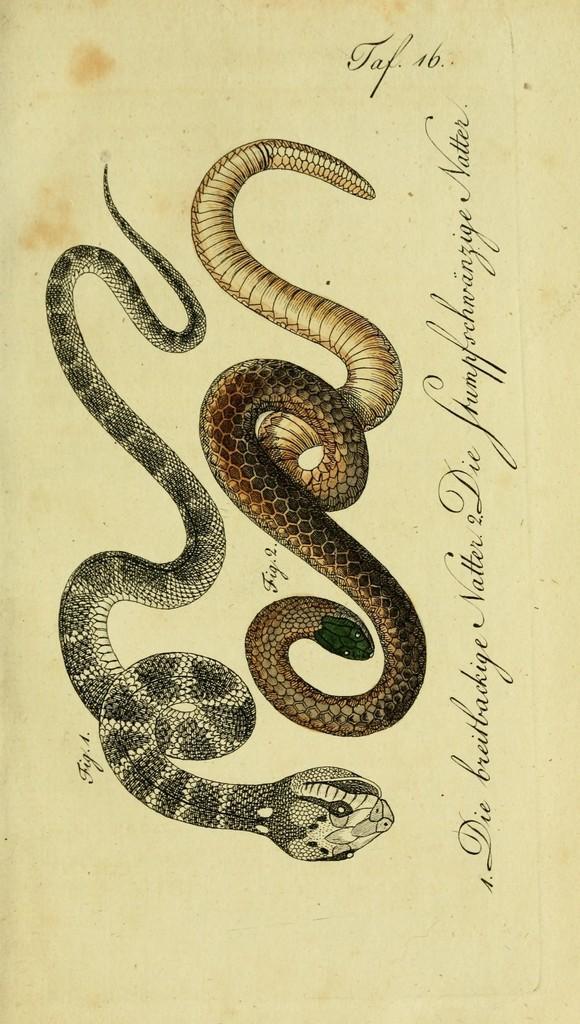Please provide a concise description of this image. This is a page and on this page we can see snakes and some text. 